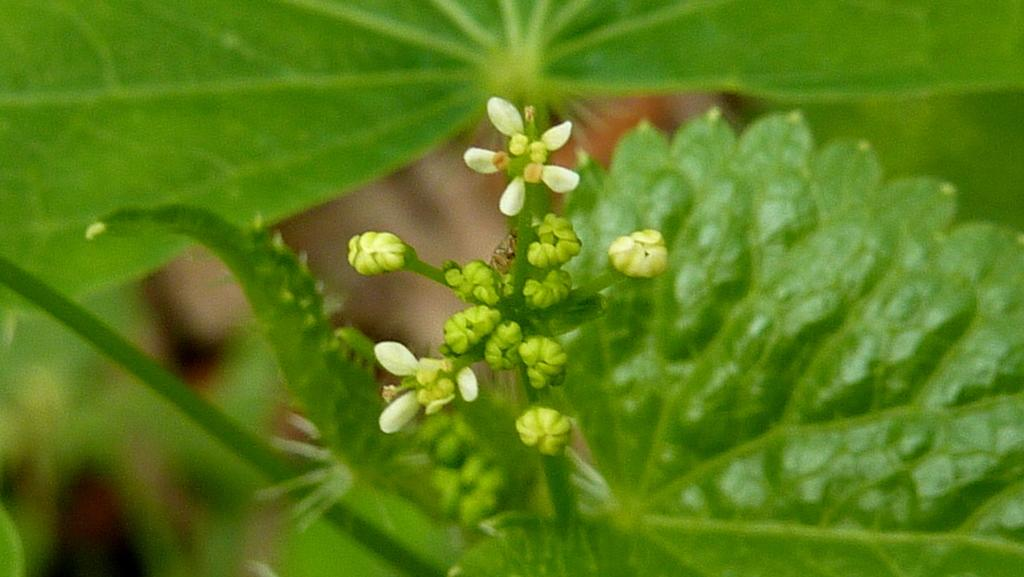What type of plant can be seen in the image? There is a flower and buds to a plant in the image. What parts of the plant are visible in the image? Leaves are also visible in the image. What type of patch does the sister wear on her arm in the image? There is no sister or patch present in the image; it only features a flower, buds, and leaves. 